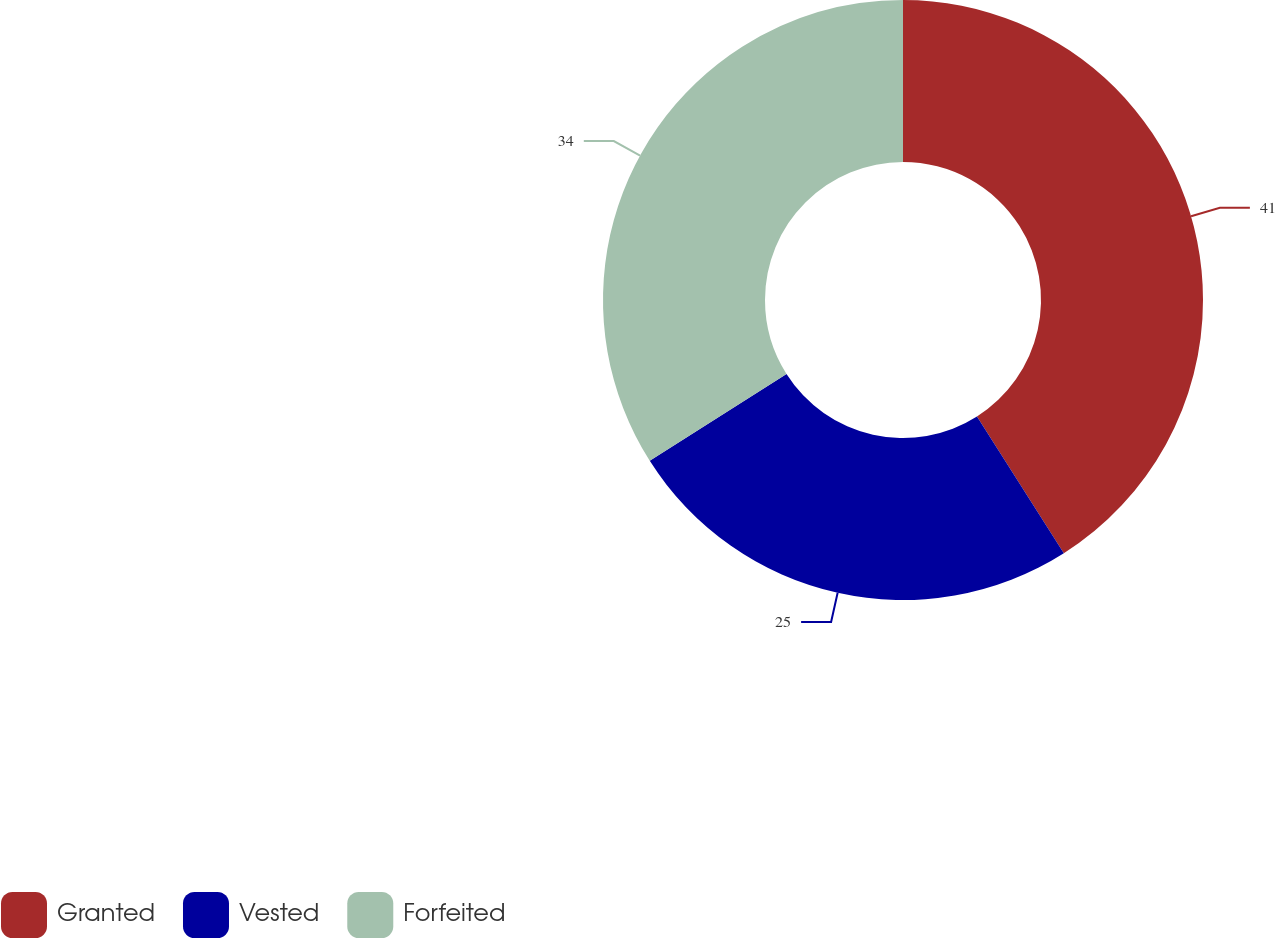Convert chart to OTSL. <chart><loc_0><loc_0><loc_500><loc_500><pie_chart><fcel>Granted<fcel>Vested<fcel>Forfeited<nl><fcel>40.99%<fcel>25.0%<fcel>34.0%<nl></chart> 